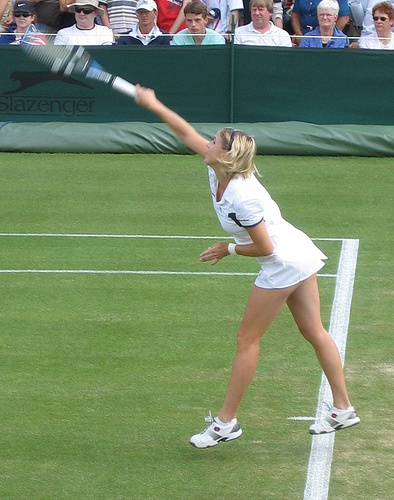Describe the objects in this image and their specific colors. I can see people in tan, white, gray, and darkgray tones, tennis racket in tan, darkgray, gray, lavender, and purple tones, people in tan, white, darkgray, black, and gray tones, people in tan, white, gray, lightpink, and darkgray tones, and people in tan, lightblue, gray, and darkgray tones in this image. 